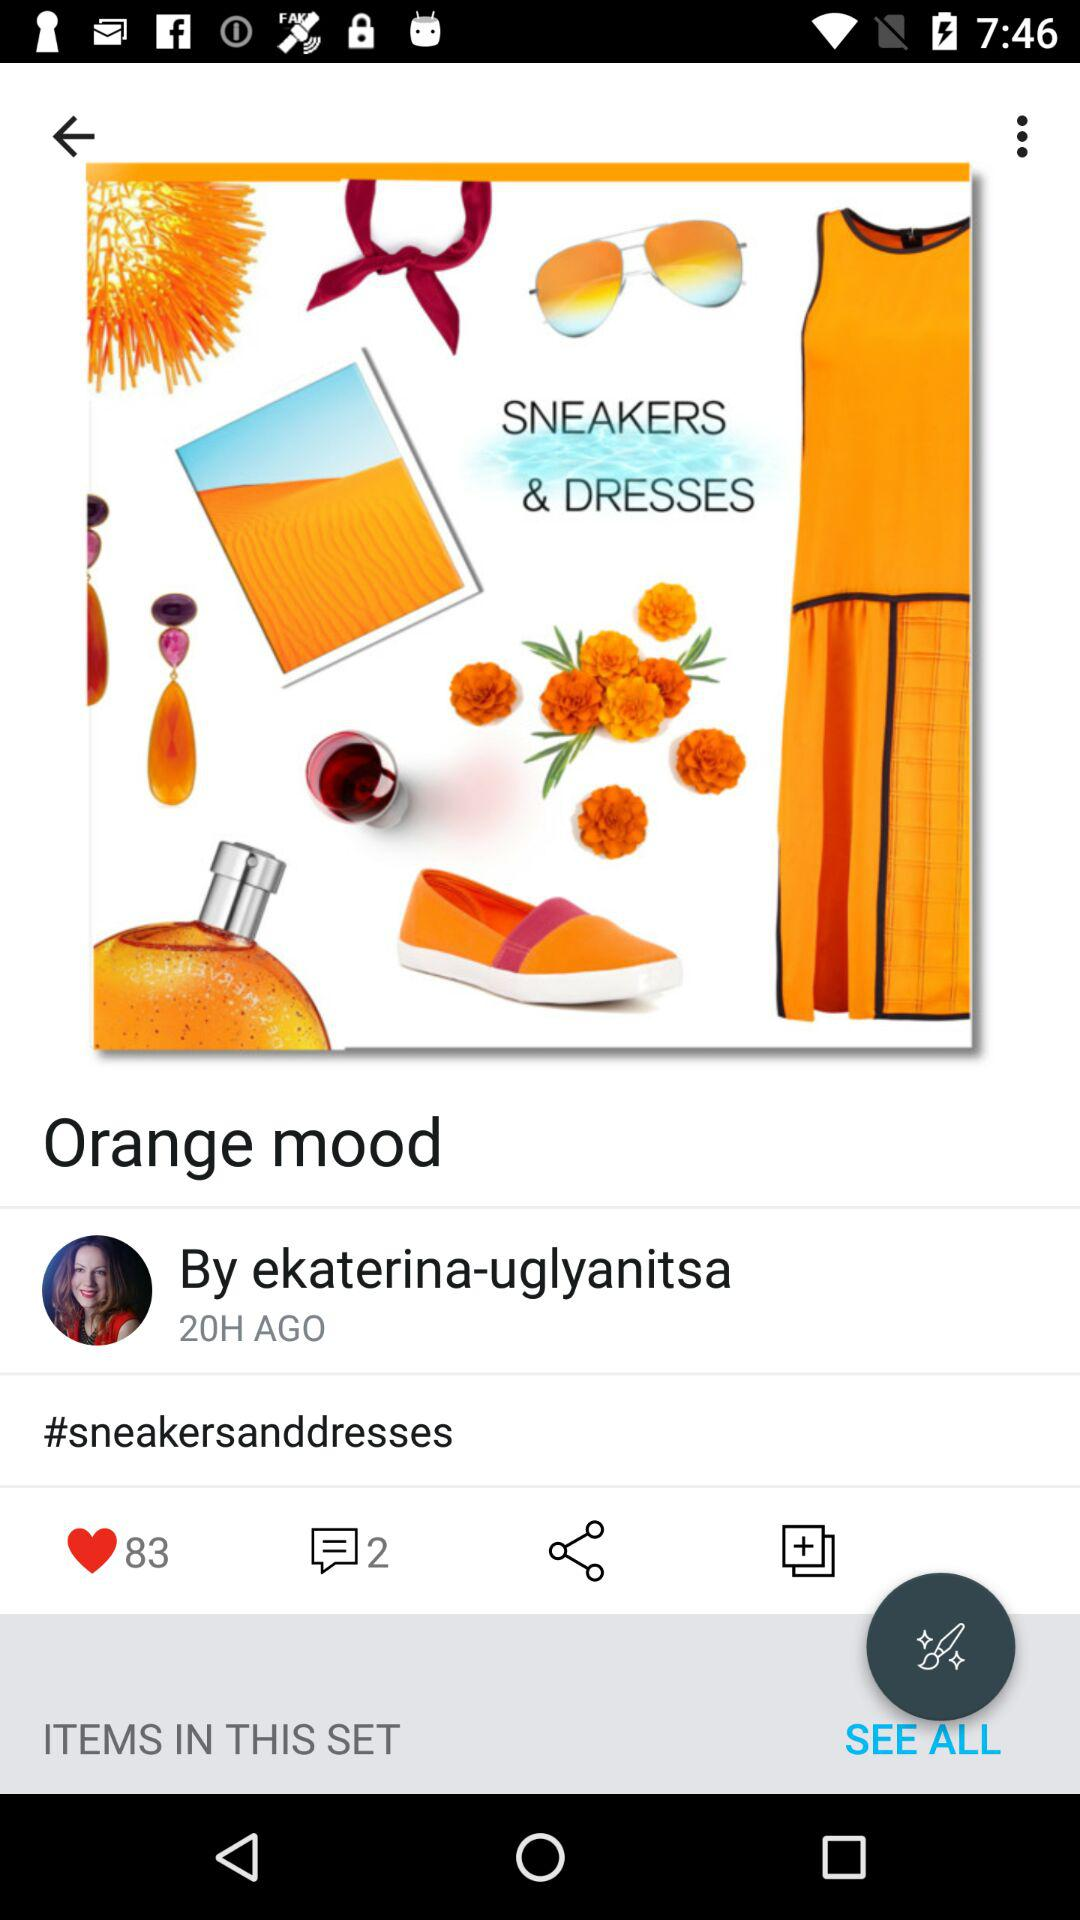How many more people have liked this post than have commented on it?
Answer the question using a single word or phrase. 81 